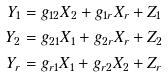<formula> <loc_0><loc_0><loc_500><loc_500>Y _ { 1 } & = g _ { 1 2 } X _ { 2 } + g _ { 1 r } X _ { r } + Z _ { 1 } \\ Y _ { 2 } & = g _ { 2 1 } X _ { 1 } + g _ { 2 r } X _ { r } + Z _ { 2 } \\ Y _ { r } & = g _ { r 1 } X _ { 1 } + g _ { r 2 } X _ { 2 } + Z _ { r }</formula> 